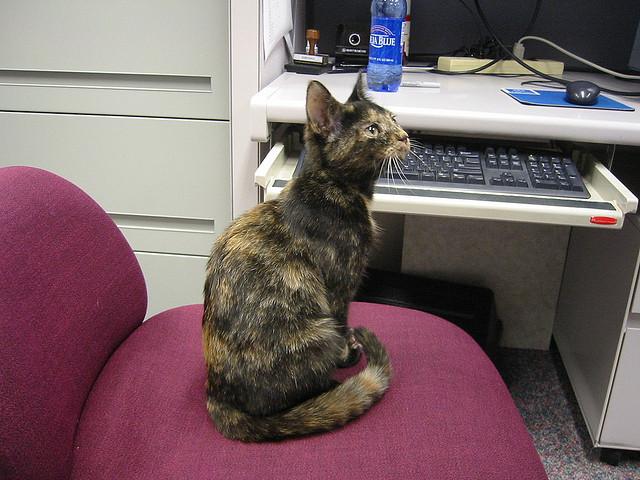What beverage is on the desk?
Keep it brief. Water. Is this cat looking at the computer mouse?
Answer briefly. No. Is the cat sitting on an office chair?
Concise answer only. Yes. 